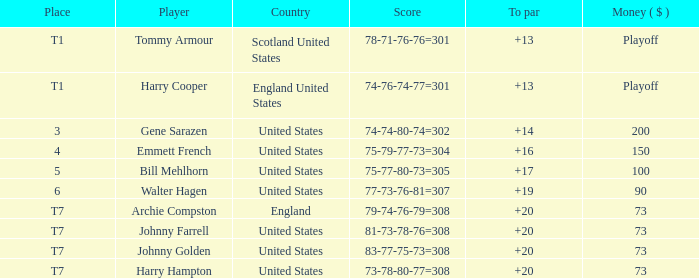What is the rating for the united states when the sum is $200? 3.0. 